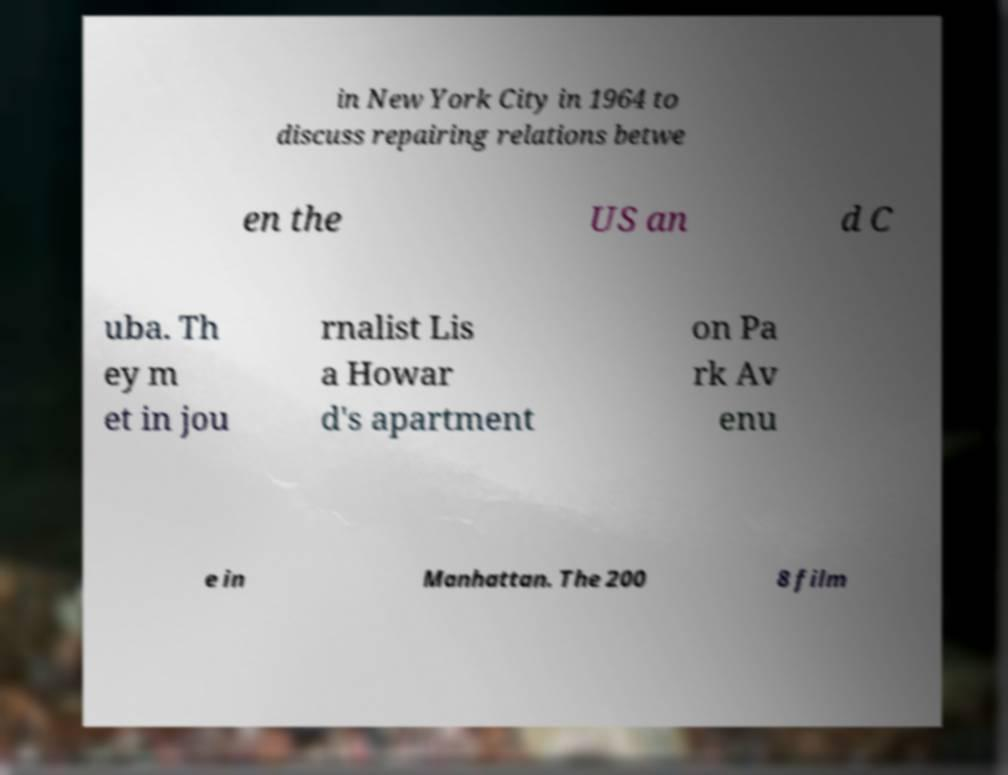For documentation purposes, I need the text within this image transcribed. Could you provide that? in New York City in 1964 to discuss repairing relations betwe en the US an d C uba. Th ey m et in jou rnalist Lis a Howar d's apartment on Pa rk Av enu e in Manhattan. The 200 8 film 